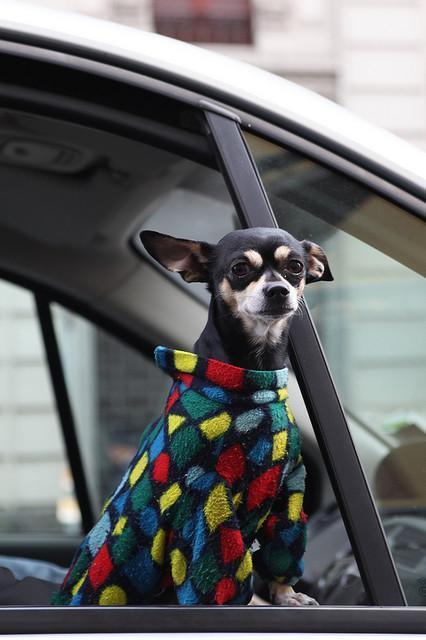How many prongs does the fork have?
Give a very brief answer. 0. 